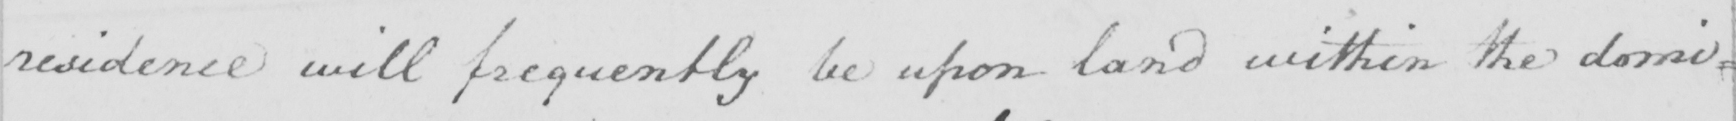Can you tell me what this handwritten text says? residence will frequently be upon land within the domi= 